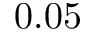<formula> <loc_0><loc_0><loc_500><loc_500>0 . 0 5</formula> 